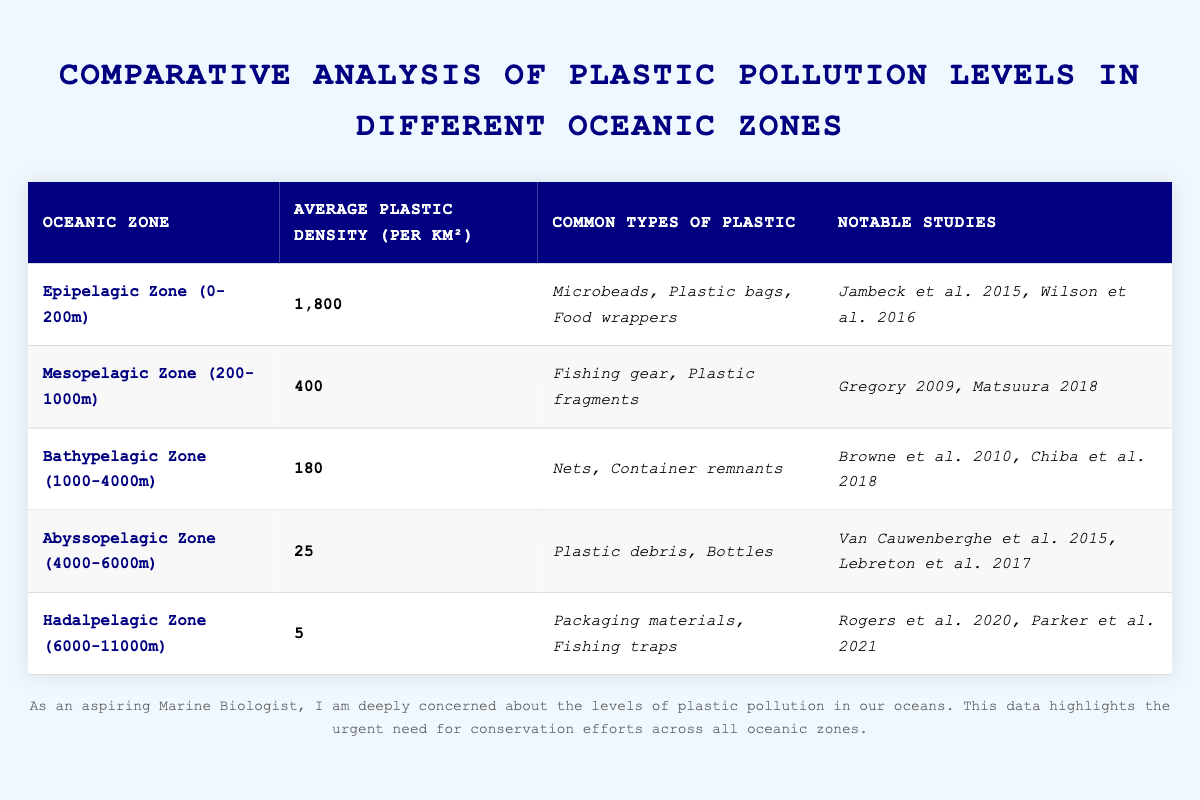What is the average plastic density in the Epipelagic Zone? The data for the Epipelagic Zone shows an average plastic density of 1,800 per square kilometer.
Answer: 1,800 Which oceanic zone has the lowest average plastic density? The Hadalpelagic Zone has the lowest average plastic density at 5 per square kilometer.
Answer: Hadalpelagic Zone How many common types of plastic are listed for the Mesopelagic Zone? The Mesopelagic Zone lists two common types of plastic: Fishing gear and Plastic fragments.
Answer: 2 What is the difference in average plastic density between the Epipelagic Zone and Abyssopelagic Zone? The Epipelagic Zone has an average density of 1,800, while the Abyssopelagic Zone has 25. The difference is 1,800 - 25 = 1,775.
Answer: 1,775 Is fishing gear listed as a common type of plastic in the Epipelagic Zone? No, fishing gear is not listed in the Epipelagic Zone; it is mentioned in the Mesopelagic Zone.
Answer: No Which oceanic zone has an average plastic density greater than 100? The Epipelagic Zone (1,800), Mesopelagic Zone (400), and Bathypelagic Zone (180) all have a density greater than 100.
Answer: Epipelagic Zone, Mesopelagic Zone, Bathypelagic Zone What are the notable studies associated with the Abyssopelagic Zone? The notable studies for the Abyssopelagic Zone are Van Cauwenberghe et al. 2015 and Lebreton et al. 2017.
Answer: Van Cauwenberghe et al. 2015, Lebreton et al. 2017 Calculate the average plastic density across all zones listed. The average plastic density can be calculated by summing all densities: 1,800 + 400 + 180 + 25 + 5 = 2,410, and dividing by the number of zones (5): 2,410 / 5 = 482.
Answer: 482 What types of plastic are most common in the Bathypelagic Zone? The Bathypelagic Zone lists nets and container remnants as common types of plastic.
Answer: Nets, Container remnants Which oceanic zone demonstrates the most significant reduction in plastic density from the Epipelagic Zone to Hadalpelagic Zone? The reduction from the Epipelagic Zone (1,800) to the Hadalpelagic Zone (5) is the most significant at 1,795.
Answer: 1,795 